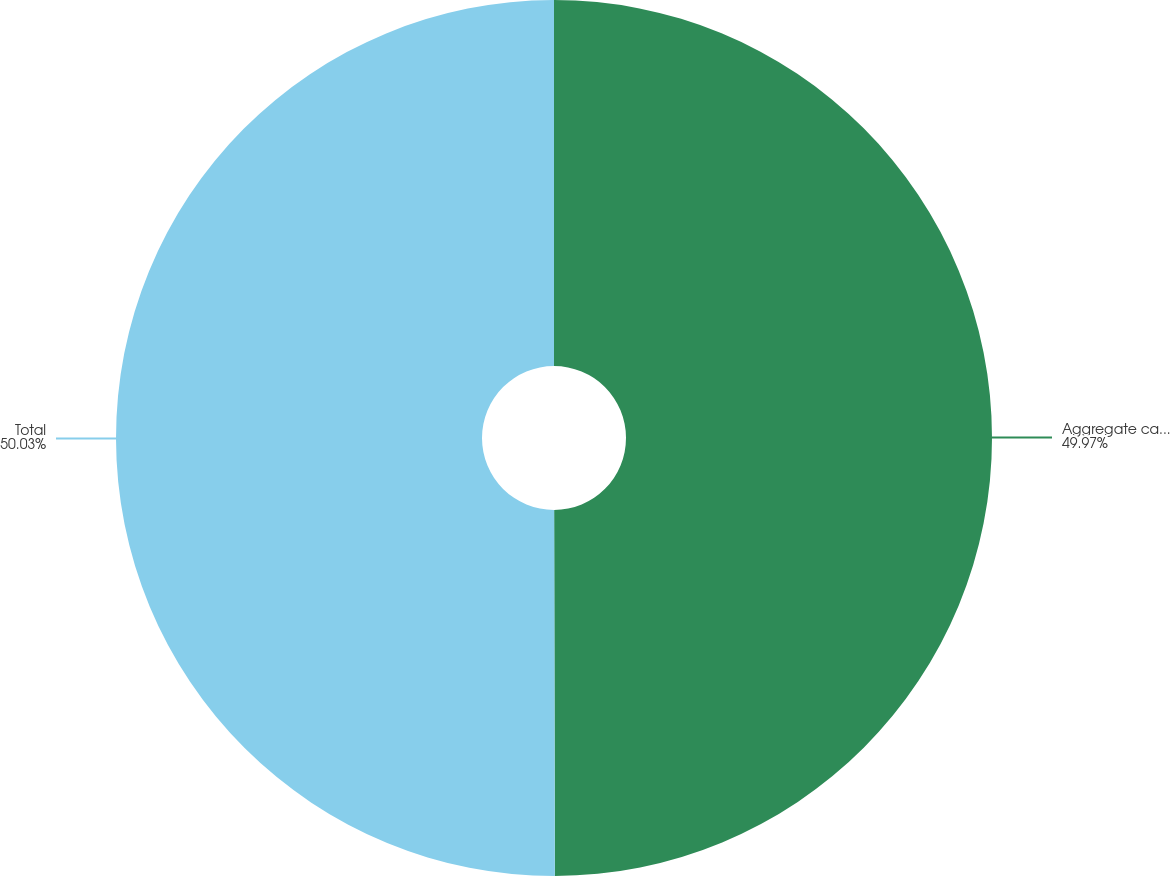Convert chart. <chart><loc_0><loc_0><loc_500><loc_500><pie_chart><fcel>Aggregate cash payments<fcel>Total<nl><fcel>49.97%<fcel>50.03%<nl></chart> 